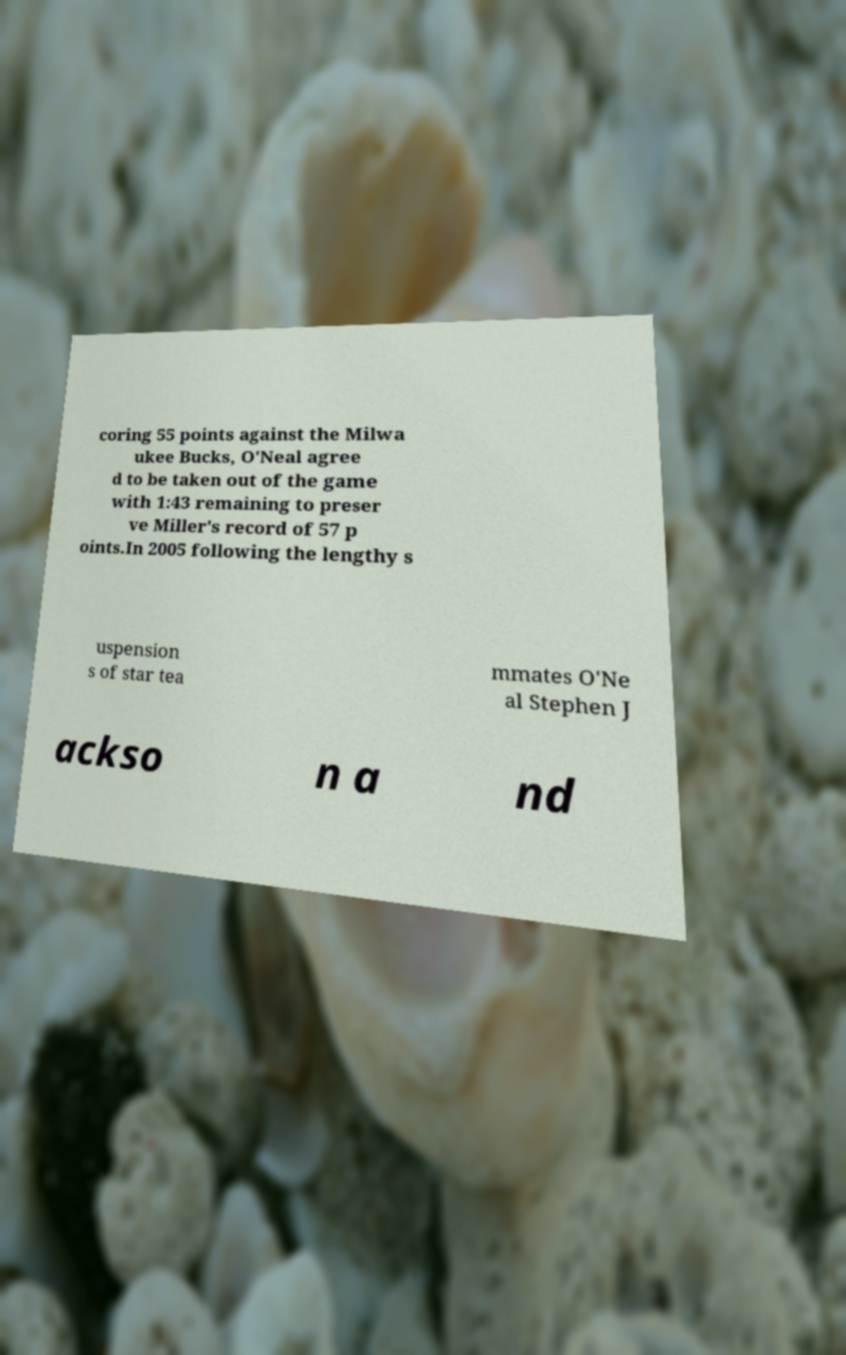There's text embedded in this image that I need extracted. Can you transcribe it verbatim? coring 55 points against the Milwa ukee Bucks, O'Neal agree d to be taken out of the game with 1:43 remaining to preser ve Miller's record of 57 p oints.In 2005 following the lengthy s uspension s of star tea mmates O'Ne al Stephen J ackso n a nd 